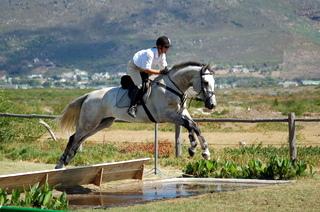Is the horse going to jump the water?
Concise answer only. Yes. What color is  the horse on the left?
Be succinct. White. What color is the horse?
Short answer required. White. How old is the girl riding the horse?
Short answer required. 15. What is the horse doing?
Short answer required. Jumping. Is he going for a walk with the horses?
Short answer required. No. Is this animal mostly found in Africa?
Quick response, please. No. Is the woman riding the lighter or the darker colored horse?
Write a very short answer. Lighter. Is the person going to fall in the water?
Give a very brief answer. No. What color is the animal?
Quick response, please. White. 